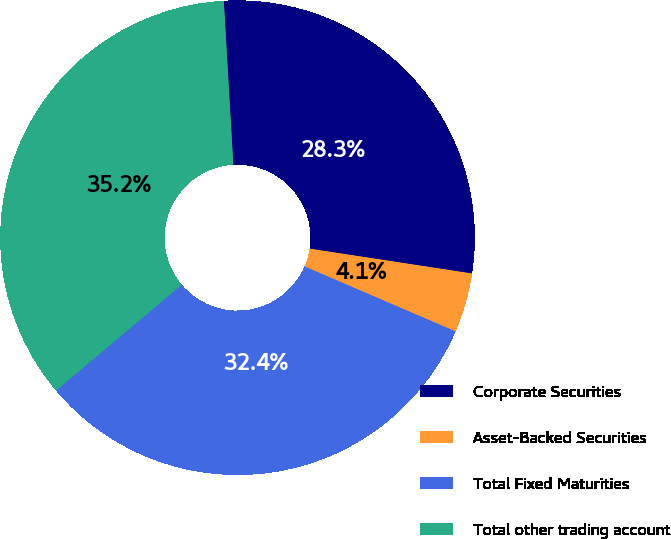<chart> <loc_0><loc_0><loc_500><loc_500><pie_chart><fcel>Corporate Securities<fcel>Asset-Backed Securities<fcel>Total Fixed Maturities<fcel>Total other trading account<nl><fcel>28.34%<fcel>4.05%<fcel>32.39%<fcel>35.22%<nl></chart> 